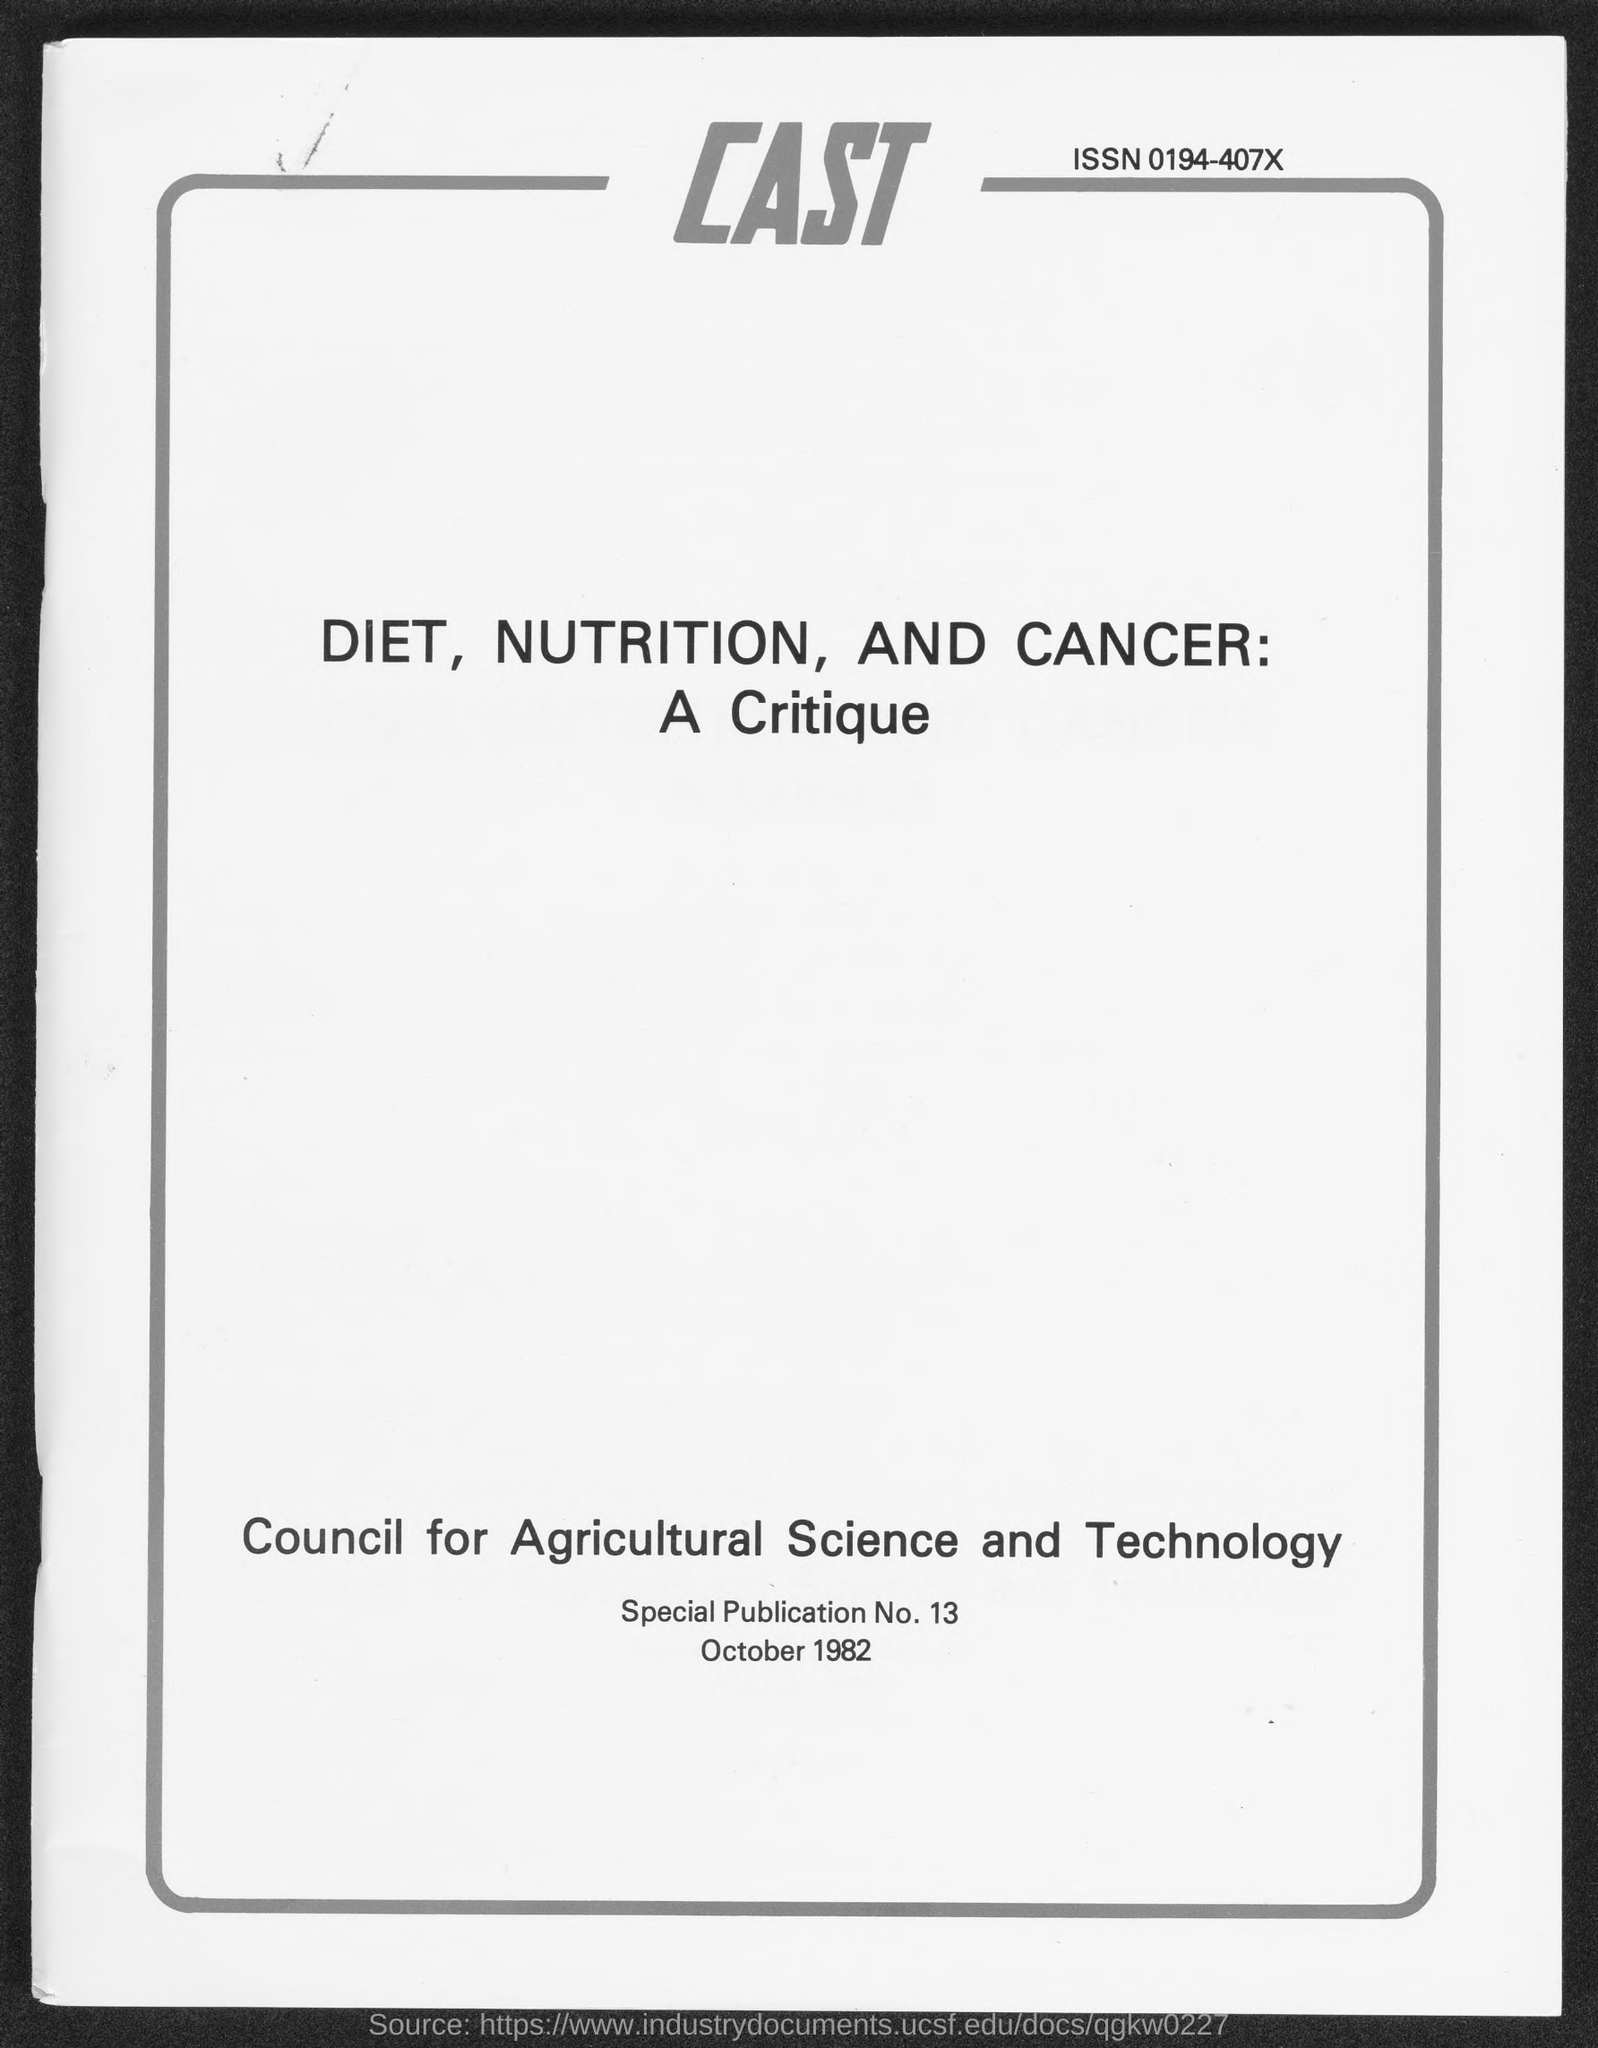What is the Special Publication Number ?
Keep it short and to the point. Special Publiction No. 13. 